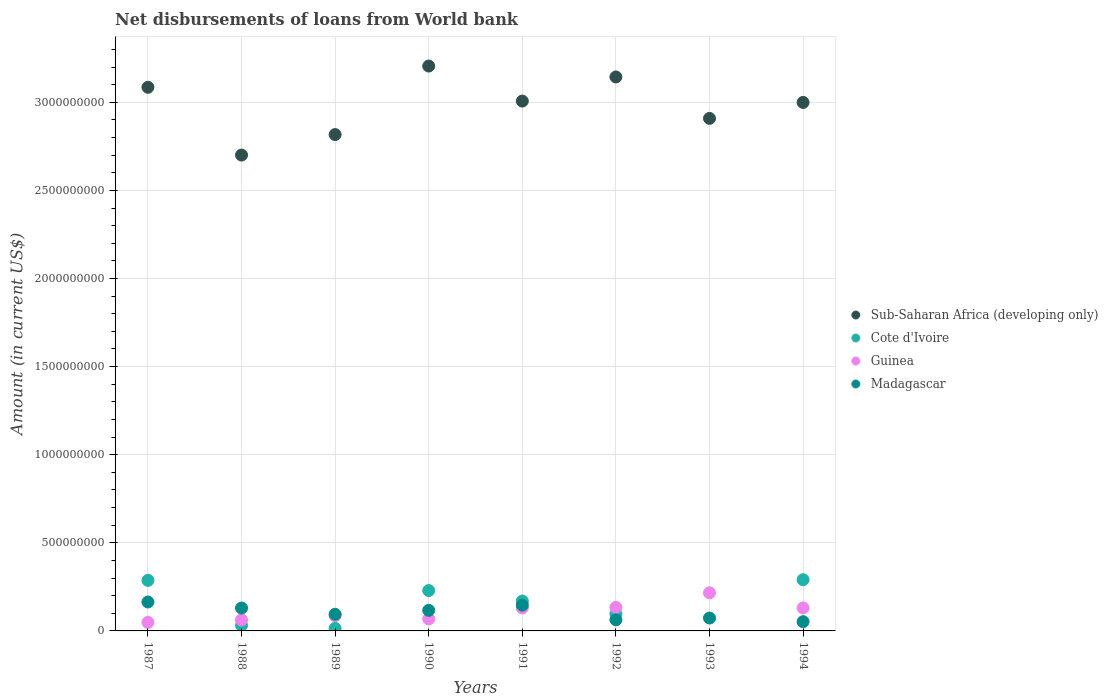What is the amount of loan disbursed from World Bank in Madagascar in 1994?
Your answer should be compact. 5.24e+07. Across all years, what is the maximum amount of loan disbursed from World Bank in Sub-Saharan Africa (developing only)?
Provide a short and direct response. 3.21e+09. In which year was the amount of loan disbursed from World Bank in Cote d'Ivoire maximum?
Keep it short and to the point. 1994. What is the total amount of loan disbursed from World Bank in Sub-Saharan Africa (developing only) in the graph?
Make the answer very short. 2.39e+1. What is the difference between the amount of loan disbursed from World Bank in Sub-Saharan Africa (developing only) in 1987 and that in 1991?
Offer a terse response. 7.83e+07. What is the difference between the amount of loan disbursed from World Bank in Madagascar in 1991 and the amount of loan disbursed from World Bank in Cote d'Ivoire in 1990?
Ensure brevity in your answer.  -8.31e+07. What is the average amount of loan disbursed from World Bank in Cote d'Ivoire per year?
Ensure brevity in your answer.  1.40e+08. In the year 1990, what is the difference between the amount of loan disbursed from World Bank in Cote d'Ivoire and amount of loan disbursed from World Bank in Sub-Saharan Africa (developing only)?
Provide a succinct answer. -2.98e+09. What is the ratio of the amount of loan disbursed from World Bank in Guinea in 1988 to that in 1989?
Offer a very short reply. 0.72. Is the amount of loan disbursed from World Bank in Cote d'Ivoire in 1987 less than that in 1989?
Provide a short and direct response. No. Is the difference between the amount of loan disbursed from World Bank in Cote d'Ivoire in 1988 and 1990 greater than the difference between the amount of loan disbursed from World Bank in Sub-Saharan Africa (developing only) in 1988 and 1990?
Keep it short and to the point. Yes. What is the difference between the highest and the second highest amount of loan disbursed from World Bank in Guinea?
Your response must be concise. 8.31e+07. What is the difference between the highest and the lowest amount of loan disbursed from World Bank in Cote d'Ivoire?
Your response must be concise. 2.91e+08. Is the sum of the amount of loan disbursed from World Bank in Guinea in 1988 and 1991 greater than the maximum amount of loan disbursed from World Bank in Sub-Saharan Africa (developing only) across all years?
Give a very brief answer. No. Is the amount of loan disbursed from World Bank in Sub-Saharan Africa (developing only) strictly greater than the amount of loan disbursed from World Bank in Cote d'Ivoire over the years?
Your answer should be very brief. Yes. Is the amount of loan disbursed from World Bank in Sub-Saharan Africa (developing only) strictly less than the amount of loan disbursed from World Bank in Madagascar over the years?
Offer a very short reply. No. How many dotlines are there?
Provide a short and direct response. 4. How many years are there in the graph?
Keep it short and to the point. 8. What is the difference between two consecutive major ticks on the Y-axis?
Make the answer very short. 5.00e+08. Does the graph contain grids?
Ensure brevity in your answer.  Yes. Where does the legend appear in the graph?
Your response must be concise. Center right. How are the legend labels stacked?
Your answer should be very brief. Vertical. What is the title of the graph?
Your response must be concise. Net disbursements of loans from World bank. What is the label or title of the X-axis?
Make the answer very short. Years. What is the label or title of the Y-axis?
Ensure brevity in your answer.  Amount (in current US$). What is the Amount (in current US$) of Sub-Saharan Africa (developing only) in 1987?
Offer a terse response. 3.09e+09. What is the Amount (in current US$) in Cote d'Ivoire in 1987?
Give a very brief answer. 2.87e+08. What is the Amount (in current US$) in Guinea in 1987?
Keep it short and to the point. 4.83e+07. What is the Amount (in current US$) in Madagascar in 1987?
Ensure brevity in your answer.  1.64e+08. What is the Amount (in current US$) of Sub-Saharan Africa (developing only) in 1988?
Provide a succinct answer. 2.70e+09. What is the Amount (in current US$) in Cote d'Ivoire in 1988?
Provide a short and direct response. 3.14e+07. What is the Amount (in current US$) of Guinea in 1988?
Make the answer very short. 6.24e+07. What is the Amount (in current US$) of Madagascar in 1988?
Offer a very short reply. 1.30e+08. What is the Amount (in current US$) of Sub-Saharan Africa (developing only) in 1989?
Your answer should be very brief. 2.82e+09. What is the Amount (in current US$) in Cote d'Ivoire in 1989?
Your answer should be very brief. 1.43e+07. What is the Amount (in current US$) in Guinea in 1989?
Your response must be concise. 8.67e+07. What is the Amount (in current US$) in Madagascar in 1989?
Provide a succinct answer. 9.44e+07. What is the Amount (in current US$) of Sub-Saharan Africa (developing only) in 1990?
Offer a terse response. 3.21e+09. What is the Amount (in current US$) of Cote d'Ivoire in 1990?
Offer a very short reply. 2.29e+08. What is the Amount (in current US$) of Guinea in 1990?
Make the answer very short. 6.82e+07. What is the Amount (in current US$) in Madagascar in 1990?
Your response must be concise. 1.17e+08. What is the Amount (in current US$) in Sub-Saharan Africa (developing only) in 1991?
Ensure brevity in your answer.  3.01e+09. What is the Amount (in current US$) of Cote d'Ivoire in 1991?
Keep it short and to the point. 1.70e+08. What is the Amount (in current US$) in Guinea in 1991?
Provide a succinct answer. 1.31e+08. What is the Amount (in current US$) in Madagascar in 1991?
Make the answer very short. 1.46e+08. What is the Amount (in current US$) in Sub-Saharan Africa (developing only) in 1992?
Your response must be concise. 3.14e+09. What is the Amount (in current US$) of Cote d'Ivoire in 1992?
Your answer should be very brief. 9.70e+07. What is the Amount (in current US$) of Guinea in 1992?
Offer a very short reply. 1.33e+08. What is the Amount (in current US$) in Madagascar in 1992?
Your response must be concise. 6.29e+07. What is the Amount (in current US$) in Sub-Saharan Africa (developing only) in 1993?
Give a very brief answer. 2.91e+09. What is the Amount (in current US$) in Cote d'Ivoire in 1993?
Your answer should be compact. 0. What is the Amount (in current US$) of Guinea in 1993?
Offer a terse response. 2.16e+08. What is the Amount (in current US$) in Madagascar in 1993?
Your answer should be very brief. 7.31e+07. What is the Amount (in current US$) of Sub-Saharan Africa (developing only) in 1994?
Offer a terse response. 3.00e+09. What is the Amount (in current US$) of Cote d'Ivoire in 1994?
Offer a very short reply. 2.91e+08. What is the Amount (in current US$) in Guinea in 1994?
Your answer should be compact. 1.31e+08. What is the Amount (in current US$) in Madagascar in 1994?
Ensure brevity in your answer.  5.24e+07. Across all years, what is the maximum Amount (in current US$) of Sub-Saharan Africa (developing only)?
Ensure brevity in your answer.  3.21e+09. Across all years, what is the maximum Amount (in current US$) of Cote d'Ivoire?
Provide a succinct answer. 2.91e+08. Across all years, what is the maximum Amount (in current US$) in Guinea?
Your answer should be compact. 2.16e+08. Across all years, what is the maximum Amount (in current US$) in Madagascar?
Provide a short and direct response. 1.64e+08. Across all years, what is the minimum Amount (in current US$) in Sub-Saharan Africa (developing only)?
Ensure brevity in your answer.  2.70e+09. Across all years, what is the minimum Amount (in current US$) of Guinea?
Your answer should be compact. 4.83e+07. Across all years, what is the minimum Amount (in current US$) of Madagascar?
Provide a short and direct response. 5.24e+07. What is the total Amount (in current US$) of Sub-Saharan Africa (developing only) in the graph?
Provide a succinct answer. 2.39e+1. What is the total Amount (in current US$) in Cote d'Ivoire in the graph?
Keep it short and to the point. 1.12e+09. What is the total Amount (in current US$) of Guinea in the graph?
Your answer should be compact. 8.77e+08. What is the total Amount (in current US$) in Madagascar in the graph?
Your response must be concise. 8.40e+08. What is the difference between the Amount (in current US$) in Sub-Saharan Africa (developing only) in 1987 and that in 1988?
Make the answer very short. 3.85e+08. What is the difference between the Amount (in current US$) of Cote d'Ivoire in 1987 and that in 1988?
Keep it short and to the point. 2.55e+08. What is the difference between the Amount (in current US$) of Guinea in 1987 and that in 1988?
Your answer should be compact. -1.41e+07. What is the difference between the Amount (in current US$) in Madagascar in 1987 and that in 1988?
Ensure brevity in your answer.  3.42e+07. What is the difference between the Amount (in current US$) of Sub-Saharan Africa (developing only) in 1987 and that in 1989?
Make the answer very short. 2.68e+08. What is the difference between the Amount (in current US$) of Cote d'Ivoire in 1987 and that in 1989?
Offer a very short reply. 2.72e+08. What is the difference between the Amount (in current US$) in Guinea in 1987 and that in 1989?
Offer a very short reply. -3.84e+07. What is the difference between the Amount (in current US$) of Madagascar in 1987 and that in 1989?
Provide a succinct answer. 6.98e+07. What is the difference between the Amount (in current US$) of Sub-Saharan Africa (developing only) in 1987 and that in 1990?
Your answer should be compact. -1.20e+08. What is the difference between the Amount (in current US$) of Cote d'Ivoire in 1987 and that in 1990?
Provide a succinct answer. 5.76e+07. What is the difference between the Amount (in current US$) in Guinea in 1987 and that in 1990?
Offer a terse response. -1.99e+07. What is the difference between the Amount (in current US$) of Madagascar in 1987 and that in 1990?
Ensure brevity in your answer.  4.74e+07. What is the difference between the Amount (in current US$) in Sub-Saharan Africa (developing only) in 1987 and that in 1991?
Make the answer very short. 7.83e+07. What is the difference between the Amount (in current US$) of Cote d'Ivoire in 1987 and that in 1991?
Give a very brief answer. 1.17e+08. What is the difference between the Amount (in current US$) of Guinea in 1987 and that in 1991?
Offer a terse response. -8.24e+07. What is the difference between the Amount (in current US$) in Madagascar in 1987 and that in 1991?
Ensure brevity in your answer.  1.81e+07. What is the difference between the Amount (in current US$) in Sub-Saharan Africa (developing only) in 1987 and that in 1992?
Your answer should be compact. -5.87e+07. What is the difference between the Amount (in current US$) in Cote d'Ivoire in 1987 and that in 1992?
Keep it short and to the point. 1.90e+08. What is the difference between the Amount (in current US$) of Guinea in 1987 and that in 1992?
Keep it short and to the point. -8.50e+07. What is the difference between the Amount (in current US$) in Madagascar in 1987 and that in 1992?
Provide a succinct answer. 1.01e+08. What is the difference between the Amount (in current US$) in Sub-Saharan Africa (developing only) in 1987 and that in 1993?
Make the answer very short. 1.77e+08. What is the difference between the Amount (in current US$) of Guinea in 1987 and that in 1993?
Your response must be concise. -1.68e+08. What is the difference between the Amount (in current US$) of Madagascar in 1987 and that in 1993?
Your answer should be very brief. 9.11e+07. What is the difference between the Amount (in current US$) in Sub-Saharan Africa (developing only) in 1987 and that in 1994?
Offer a terse response. 8.60e+07. What is the difference between the Amount (in current US$) in Cote d'Ivoire in 1987 and that in 1994?
Your response must be concise. -3.87e+06. What is the difference between the Amount (in current US$) of Guinea in 1987 and that in 1994?
Your response must be concise. -8.23e+07. What is the difference between the Amount (in current US$) of Madagascar in 1987 and that in 1994?
Ensure brevity in your answer.  1.12e+08. What is the difference between the Amount (in current US$) of Sub-Saharan Africa (developing only) in 1988 and that in 1989?
Ensure brevity in your answer.  -1.16e+08. What is the difference between the Amount (in current US$) in Cote d'Ivoire in 1988 and that in 1989?
Offer a very short reply. 1.71e+07. What is the difference between the Amount (in current US$) in Guinea in 1988 and that in 1989?
Provide a succinct answer. -2.43e+07. What is the difference between the Amount (in current US$) of Madagascar in 1988 and that in 1989?
Your answer should be very brief. 3.56e+07. What is the difference between the Amount (in current US$) of Sub-Saharan Africa (developing only) in 1988 and that in 1990?
Provide a succinct answer. -5.05e+08. What is the difference between the Amount (in current US$) of Cote d'Ivoire in 1988 and that in 1990?
Offer a very short reply. -1.98e+08. What is the difference between the Amount (in current US$) of Guinea in 1988 and that in 1990?
Ensure brevity in your answer.  -5.80e+06. What is the difference between the Amount (in current US$) of Madagascar in 1988 and that in 1990?
Your response must be concise. 1.32e+07. What is the difference between the Amount (in current US$) of Sub-Saharan Africa (developing only) in 1988 and that in 1991?
Provide a succinct answer. -3.06e+08. What is the difference between the Amount (in current US$) of Cote d'Ivoire in 1988 and that in 1991?
Your response must be concise. -1.38e+08. What is the difference between the Amount (in current US$) in Guinea in 1988 and that in 1991?
Keep it short and to the point. -6.82e+07. What is the difference between the Amount (in current US$) of Madagascar in 1988 and that in 1991?
Ensure brevity in your answer.  -1.61e+07. What is the difference between the Amount (in current US$) in Sub-Saharan Africa (developing only) in 1988 and that in 1992?
Your response must be concise. -4.43e+08. What is the difference between the Amount (in current US$) in Cote d'Ivoire in 1988 and that in 1992?
Offer a very short reply. -6.56e+07. What is the difference between the Amount (in current US$) of Guinea in 1988 and that in 1992?
Provide a succinct answer. -7.09e+07. What is the difference between the Amount (in current US$) in Madagascar in 1988 and that in 1992?
Provide a short and direct response. 6.71e+07. What is the difference between the Amount (in current US$) in Sub-Saharan Africa (developing only) in 1988 and that in 1993?
Provide a short and direct response. -2.08e+08. What is the difference between the Amount (in current US$) of Guinea in 1988 and that in 1993?
Your answer should be compact. -1.54e+08. What is the difference between the Amount (in current US$) of Madagascar in 1988 and that in 1993?
Ensure brevity in your answer.  5.68e+07. What is the difference between the Amount (in current US$) in Sub-Saharan Africa (developing only) in 1988 and that in 1994?
Offer a very short reply. -2.99e+08. What is the difference between the Amount (in current US$) in Cote d'Ivoire in 1988 and that in 1994?
Provide a succinct answer. -2.59e+08. What is the difference between the Amount (in current US$) in Guinea in 1988 and that in 1994?
Provide a short and direct response. -6.82e+07. What is the difference between the Amount (in current US$) in Madagascar in 1988 and that in 1994?
Ensure brevity in your answer.  7.76e+07. What is the difference between the Amount (in current US$) of Sub-Saharan Africa (developing only) in 1989 and that in 1990?
Provide a short and direct response. -3.89e+08. What is the difference between the Amount (in current US$) of Cote d'Ivoire in 1989 and that in 1990?
Give a very brief answer. -2.15e+08. What is the difference between the Amount (in current US$) of Guinea in 1989 and that in 1990?
Your answer should be very brief. 1.85e+07. What is the difference between the Amount (in current US$) of Madagascar in 1989 and that in 1990?
Ensure brevity in your answer.  -2.23e+07. What is the difference between the Amount (in current US$) in Sub-Saharan Africa (developing only) in 1989 and that in 1991?
Your answer should be very brief. -1.90e+08. What is the difference between the Amount (in current US$) of Cote d'Ivoire in 1989 and that in 1991?
Your answer should be compact. -1.56e+08. What is the difference between the Amount (in current US$) in Guinea in 1989 and that in 1991?
Provide a succinct answer. -4.40e+07. What is the difference between the Amount (in current US$) in Madagascar in 1989 and that in 1991?
Provide a succinct answer. -5.17e+07. What is the difference between the Amount (in current US$) in Sub-Saharan Africa (developing only) in 1989 and that in 1992?
Keep it short and to the point. -3.27e+08. What is the difference between the Amount (in current US$) of Cote d'Ivoire in 1989 and that in 1992?
Ensure brevity in your answer.  -8.27e+07. What is the difference between the Amount (in current US$) in Guinea in 1989 and that in 1992?
Your answer should be very brief. -4.66e+07. What is the difference between the Amount (in current US$) in Madagascar in 1989 and that in 1992?
Your answer should be very brief. 3.15e+07. What is the difference between the Amount (in current US$) in Sub-Saharan Africa (developing only) in 1989 and that in 1993?
Provide a short and direct response. -9.18e+07. What is the difference between the Amount (in current US$) in Guinea in 1989 and that in 1993?
Provide a succinct answer. -1.30e+08. What is the difference between the Amount (in current US$) in Madagascar in 1989 and that in 1993?
Provide a short and direct response. 2.13e+07. What is the difference between the Amount (in current US$) of Sub-Saharan Africa (developing only) in 1989 and that in 1994?
Your answer should be compact. -1.82e+08. What is the difference between the Amount (in current US$) in Cote d'Ivoire in 1989 and that in 1994?
Give a very brief answer. -2.76e+08. What is the difference between the Amount (in current US$) of Guinea in 1989 and that in 1994?
Your answer should be compact. -4.40e+07. What is the difference between the Amount (in current US$) in Madagascar in 1989 and that in 1994?
Your response must be concise. 4.21e+07. What is the difference between the Amount (in current US$) of Sub-Saharan Africa (developing only) in 1990 and that in 1991?
Offer a very short reply. 1.99e+08. What is the difference between the Amount (in current US$) in Cote d'Ivoire in 1990 and that in 1991?
Your response must be concise. 5.94e+07. What is the difference between the Amount (in current US$) of Guinea in 1990 and that in 1991?
Keep it short and to the point. -6.25e+07. What is the difference between the Amount (in current US$) of Madagascar in 1990 and that in 1991?
Give a very brief answer. -2.94e+07. What is the difference between the Amount (in current US$) in Sub-Saharan Africa (developing only) in 1990 and that in 1992?
Your response must be concise. 6.18e+07. What is the difference between the Amount (in current US$) in Cote d'Ivoire in 1990 and that in 1992?
Offer a very short reply. 1.32e+08. What is the difference between the Amount (in current US$) of Guinea in 1990 and that in 1992?
Make the answer very short. -6.51e+07. What is the difference between the Amount (in current US$) in Madagascar in 1990 and that in 1992?
Your answer should be compact. 5.39e+07. What is the difference between the Amount (in current US$) in Sub-Saharan Africa (developing only) in 1990 and that in 1993?
Your answer should be compact. 2.97e+08. What is the difference between the Amount (in current US$) of Guinea in 1990 and that in 1993?
Keep it short and to the point. -1.48e+08. What is the difference between the Amount (in current US$) of Madagascar in 1990 and that in 1993?
Give a very brief answer. 4.36e+07. What is the difference between the Amount (in current US$) in Sub-Saharan Africa (developing only) in 1990 and that in 1994?
Offer a very short reply. 2.06e+08. What is the difference between the Amount (in current US$) in Cote d'Ivoire in 1990 and that in 1994?
Keep it short and to the point. -6.15e+07. What is the difference between the Amount (in current US$) in Guinea in 1990 and that in 1994?
Offer a very short reply. -6.24e+07. What is the difference between the Amount (in current US$) of Madagascar in 1990 and that in 1994?
Keep it short and to the point. 6.44e+07. What is the difference between the Amount (in current US$) of Sub-Saharan Africa (developing only) in 1991 and that in 1992?
Keep it short and to the point. -1.37e+08. What is the difference between the Amount (in current US$) of Cote d'Ivoire in 1991 and that in 1992?
Your response must be concise. 7.29e+07. What is the difference between the Amount (in current US$) in Guinea in 1991 and that in 1992?
Ensure brevity in your answer.  -2.63e+06. What is the difference between the Amount (in current US$) in Madagascar in 1991 and that in 1992?
Keep it short and to the point. 8.32e+07. What is the difference between the Amount (in current US$) in Sub-Saharan Africa (developing only) in 1991 and that in 1993?
Offer a terse response. 9.82e+07. What is the difference between the Amount (in current US$) in Guinea in 1991 and that in 1993?
Offer a very short reply. -8.58e+07. What is the difference between the Amount (in current US$) of Madagascar in 1991 and that in 1993?
Offer a very short reply. 7.30e+07. What is the difference between the Amount (in current US$) in Sub-Saharan Africa (developing only) in 1991 and that in 1994?
Provide a short and direct response. 7.68e+06. What is the difference between the Amount (in current US$) of Cote d'Ivoire in 1991 and that in 1994?
Your answer should be very brief. -1.21e+08. What is the difference between the Amount (in current US$) of Guinea in 1991 and that in 1994?
Make the answer very short. 3.80e+04. What is the difference between the Amount (in current US$) in Madagascar in 1991 and that in 1994?
Your answer should be very brief. 9.37e+07. What is the difference between the Amount (in current US$) of Sub-Saharan Africa (developing only) in 1992 and that in 1993?
Give a very brief answer. 2.35e+08. What is the difference between the Amount (in current US$) of Guinea in 1992 and that in 1993?
Offer a very short reply. -8.31e+07. What is the difference between the Amount (in current US$) of Madagascar in 1992 and that in 1993?
Offer a terse response. -1.03e+07. What is the difference between the Amount (in current US$) in Sub-Saharan Africa (developing only) in 1992 and that in 1994?
Give a very brief answer. 1.45e+08. What is the difference between the Amount (in current US$) in Cote d'Ivoire in 1992 and that in 1994?
Ensure brevity in your answer.  -1.94e+08. What is the difference between the Amount (in current US$) in Guinea in 1992 and that in 1994?
Your answer should be compact. 2.67e+06. What is the difference between the Amount (in current US$) of Madagascar in 1992 and that in 1994?
Offer a terse response. 1.05e+07. What is the difference between the Amount (in current US$) in Sub-Saharan Africa (developing only) in 1993 and that in 1994?
Your response must be concise. -9.06e+07. What is the difference between the Amount (in current US$) of Guinea in 1993 and that in 1994?
Provide a succinct answer. 8.58e+07. What is the difference between the Amount (in current US$) of Madagascar in 1993 and that in 1994?
Offer a very short reply. 2.08e+07. What is the difference between the Amount (in current US$) in Sub-Saharan Africa (developing only) in 1987 and the Amount (in current US$) in Cote d'Ivoire in 1988?
Make the answer very short. 3.05e+09. What is the difference between the Amount (in current US$) of Sub-Saharan Africa (developing only) in 1987 and the Amount (in current US$) of Guinea in 1988?
Your response must be concise. 3.02e+09. What is the difference between the Amount (in current US$) in Sub-Saharan Africa (developing only) in 1987 and the Amount (in current US$) in Madagascar in 1988?
Give a very brief answer. 2.96e+09. What is the difference between the Amount (in current US$) of Cote d'Ivoire in 1987 and the Amount (in current US$) of Guinea in 1988?
Make the answer very short. 2.24e+08. What is the difference between the Amount (in current US$) in Cote d'Ivoire in 1987 and the Amount (in current US$) in Madagascar in 1988?
Your response must be concise. 1.57e+08. What is the difference between the Amount (in current US$) in Guinea in 1987 and the Amount (in current US$) in Madagascar in 1988?
Make the answer very short. -8.17e+07. What is the difference between the Amount (in current US$) of Sub-Saharan Africa (developing only) in 1987 and the Amount (in current US$) of Cote d'Ivoire in 1989?
Give a very brief answer. 3.07e+09. What is the difference between the Amount (in current US$) in Sub-Saharan Africa (developing only) in 1987 and the Amount (in current US$) in Guinea in 1989?
Offer a terse response. 3.00e+09. What is the difference between the Amount (in current US$) in Sub-Saharan Africa (developing only) in 1987 and the Amount (in current US$) in Madagascar in 1989?
Your answer should be very brief. 2.99e+09. What is the difference between the Amount (in current US$) in Cote d'Ivoire in 1987 and the Amount (in current US$) in Guinea in 1989?
Provide a short and direct response. 2.00e+08. What is the difference between the Amount (in current US$) in Cote d'Ivoire in 1987 and the Amount (in current US$) in Madagascar in 1989?
Your response must be concise. 1.92e+08. What is the difference between the Amount (in current US$) in Guinea in 1987 and the Amount (in current US$) in Madagascar in 1989?
Give a very brief answer. -4.61e+07. What is the difference between the Amount (in current US$) in Sub-Saharan Africa (developing only) in 1987 and the Amount (in current US$) in Cote d'Ivoire in 1990?
Provide a short and direct response. 2.86e+09. What is the difference between the Amount (in current US$) in Sub-Saharan Africa (developing only) in 1987 and the Amount (in current US$) in Guinea in 1990?
Give a very brief answer. 3.02e+09. What is the difference between the Amount (in current US$) in Sub-Saharan Africa (developing only) in 1987 and the Amount (in current US$) in Madagascar in 1990?
Your response must be concise. 2.97e+09. What is the difference between the Amount (in current US$) in Cote d'Ivoire in 1987 and the Amount (in current US$) in Guinea in 1990?
Your response must be concise. 2.19e+08. What is the difference between the Amount (in current US$) in Cote d'Ivoire in 1987 and the Amount (in current US$) in Madagascar in 1990?
Ensure brevity in your answer.  1.70e+08. What is the difference between the Amount (in current US$) in Guinea in 1987 and the Amount (in current US$) in Madagascar in 1990?
Give a very brief answer. -6.84e+07. What is the difference between the Amount (in current US$) in Sub-Saharan Africa (developing only) in 1987 and the Amount (in current US$) in Cote d'Ivoire in 1991?
Make the answer very short. 2.92e+09. What is the difference between the Amount (in current US$) of Sub-Saharan Africa (developing only) in 1987 and the Amount (in current US$) of Guinea in 1991?
Give a very brief answer. 2.95e+09. What is the difference between the Amount (in current US$) of Sub-Saharan Africa (developing only) in 1987 and the Amount (in current US$) of Madagascar in 1991?
Ensure brevity in your answer.  2.94e+09. What is the difference between the Amount (in current US$) of Cote d'Ivoire in 1987 and the Amount (in current US$) of Guinea in 1991?
Make the answer very short. 1.56e+08. What is the difference between the Amount (in current US$) in Cote d'Ivoire in 1987 and the Amount (in current US$) in Madagascar in 1991?
Your answer should be compact. 1.41e+08. What is the difference between the Amount (in current US$) of Guinea in 1987 and the Amount (in current US$) of Madagascar in 1991?
Make the answer very short. -9.78e+07. What is the difference between the Amount (in current US$) in Sub-Saharan Africa (developing only) in 1987 and the Amount (in current US$) in Cote d'Ivoire in 1992?
Provide a short and direct response. 2.99e+09. What is the difference between the Amount (in current US$) in Sub-Saharan Africa (developing only) in 1987 and the Amount (in current US$) in Guinea in 1992?
Offer a terse response. 2.95e+09. What is the difference between the Amount (in current US$) in Sub-Saharan Africa (developing only) in 1987 and the Amount (in current US$) in Madagascar in 1992?
Provide a succinct answer. 3.02e+09. What is the difference between the Amount (in current US$) in Cote d'Ivoire in 1987 and the Amount (in current US$) in Guinea in 1992?
Your answer should be compact. 1.54e+08. What is the difference between the Amount (in current US$) in Cote d'Ivoire in 1987 and the Amount (in current US$) in Madagascar in 1992?
Provide a short and direct response. 2.24e+08. What is the difference between the Amount (in current US$) of Guinea in 1987 and the Amount (in current US$) of Madagascar in 1992?
Make the answer very short. -1.46e+07. What is the difference between the Amount (in current US$) in Sub-Saharan Africa (developing only) in 1987 and the Amount (in current US$) in Guinea in 1993?
Your answer should be very brief. 2.87e+09. What is the difference between the Amount (in current US$) of Sub-Saharan Africa (developing only) in 1987 and the Amount (in current US$) of Madagascar in 1993?
Provide a succinct answer. 3.01e+09. What is the difference between the Amount (in current US$) of Cote d'Ivoire in 1987 and the Amount (in current US$) of Guinea in 1993?
Ensure brevity in your answer.  7.04e+07. What is the difference between the Amount (in current US$) in Cote d'Ivoire in 1987 and the Amount (in current US$) in Madagascar in 1993?
Offer a very short reply. 2.14e+08. What is the difference between the Amount (in current US$) in Guinea in 1987 and the Amount (in current US$) in Madagascar in 1993?
Offer a terse response. -2.48e+07. What is the difference between the Amount (in current US$) in Sub-Saharan Africa (developing only) in 1987 and the Amount (in current US$) in Cote d'Ivoire in 1994?
Give a very brief answer. 2.79e+09. What is the difference between the Amount (in current US$) in Sub-Saharan Africa (developing only) in 1987 and the Amount (in current US$) in Guinea in 1994?
Provide a short and direct response. 2.95e+09. What is the difference between the Amount (in current US$) in Sub-Saharan Africa (developing only) in 1987 and the Amount (in current US$) in Madagascar in 1994?
Your response must be concise. 3.03e+09. What is the difference between the Amount (in current US$) of Cote d'Ivoire in 1987 and the Amount (in current US$) of Guinea in 1994?
Make the answer very short. 1.56e+08. What is the difference between the Amount (in current US$) in Cote d'Ivoire in 1987 and the Amount (in current US$) in Madagascar in 1994?
Offer a terse response. 2.34e+08. What is the difference between the Amount (in current US$) in Guinea in 1987 and the Amount (in current US$) in Madagascar in 1994?
Provide a short and direct response. -4.06e+06. What is the difference between the Amount (in current US$) of Sub-Saharan Africa (developing only) in 1988 and the Amount (in current US$) of Cote d'Ivoire in 1989?
Provide a succinct answer. 2.69e+09. What is the difference between the Amount (in current US$) of Sub-Saharan Africa (developing only) in 1988 and the Amount (in current US$) of Guinea in 1989?
Provide a short and direct response. 2.61e+09. What is the difference between the Amount (in current US$) of Sub-Saharan Africa (developing only) in 1988 and the Amount (in current US$) of Madagascar in 1989?
Offer a very short reply. 2.61e+09. What is the difference between the Amount (in current US$) of Cote d'Ivoire in 1988 and the Amount (in current US$) of Guinea in 1989?
Make the answer very short. -5.53e+07. What is the difference between the Amount (in current US$) in Cote d'Ivoire in 1988 and the Amount (in current US$) in Madagascar in 1989?
Your answer should be very brief. -6.30e+07. What is the difference between the Amount (in current US$) in Guinea in 1988 and the Amount (in current US$) in Madagascar in 1989?
Offer a terse response. -3.20e+07. What is the difference between the Amount (in current US$) in Sub-Saharan Africa (developing only) in 1988 and the Amount (in current US$) in Cote d'Ivoire in 1990?
Keep it short and to the point. 2.47e+09. What is the difference between the Amount (in current US$) in Sub-Saharan Africa (developing only) in 1988 and the Amount (in current US$) in Guinea in 1990?
Provide a short and direct response. 2.63e+09. What is the difference between the Amount (in current US$) of Sub-Saharan Africa (developing only) in 1988 and the Amount (in current US$) of Madagascar in 1990?
Give a very brief answer. 2.58e+09. What is the difference between the Amount (in current US$) of Cote d'Ivoire in 1988 and the Amount (in current US$) of Guinea in 1990?
Your answer should be very brief. -3.68e+07. What is the difference between the Amount (in current US$) of Cote d'Ivoire in 1988 and the Amount (in current US$) of Madagascar in 1990?
Ensure brevity in your answer.  -8.53e+07. What is the difference between the Amount (in current US$) of Guinea in 1988 and the Amount (in current US$) of Madagascar in 1990?
Offer a very short reply. -5.43e+07. What is the difference between the Amount (in current US$) of Sub-Saharan Africa (developing only) in 1988 and the Amount (in current US$) of Cote d'Ivoire in 1991?
Offer a very short reply. 2.53e+09. What is the difference between the Amount (in current US$) in Sub-Saharan Africa (developing only) in 1988 and the Amount (in current US$) in Guinea in 1991?
Ensure brevity in your answer.  2.57e+09. What is the difference between the Amount (in current US$) in Sub-Saharan Africa (developing only) in 1988 and the Amount (in current US$) in Madagascar in 1991?
Give a very brief answer. 2.55e+09. What is the difference between the Amount (in current US$) of Cote d'Ivoire in 1988 and the Amount (in current US$) of Guinea in 1991?
Your answer should be compact. -9.93e+07. What is the difference between the Amount (in current US$) in Cote d'Ivoire in 1988 and the Amount (in current US$) in Madagascar in 1991?
Offer a very short reply. -1.15e+08. What is the difference between the Amount (in current US$) in Guinea in 1988 and the Amount (in current US$) in Madagascar in 1991?
Offer a very short reply. -8.37e+07. What is the difference between the Amount (in current US$) in Sub-Saharan Africa (developing only) in 1988 and the Amount (in current US$) in Cote d'Ivoire in 1992?
Make the answer very short. 2.60e+09. What is the difference between the Amount (in current US$) in Sub-Saharan Africa (developing only) in 1988 and the Amount (in current US$) in Guinea in 1992?
Provide a short and direct response. 2.57e+09. What is the difference between the Amount (in current US$) of Sub-Saharan Africa (developing only) in 1988 and the Amount (in current US$) of Madagascar in 1992?
Keep it short and to the point. 2.64e+09. What is the difference between the Amount (in current US$) in Cote d'Ivoire in 1988 and the Amount (in current US$) in Guinea in 1992?
Make the answer very short. -1.02e+08. What is the difference between the Amount (in current US$) in Cote d'Ivoire in 1988 and the Amount (in current US$) in Madagascar in 1992?
Offer a very short reply. -3.15e+07. What is the difference between the Amount (in current US$) of Guinea in 1988 and the Amount (in current US$) of Madagascar in 1992?
Give a very brief answer. -4.48e+05. What is the difference between the Amount (in current US$) of Sub-Saharan Africa (developing only) in 1988 and the Amount (in current US$) of Guinea in 1993?
Make the answer very short. 2.48e+09. What is the difference between the Amount (in current US$) in Sub-Saharan Africa (developing only) in 1988 and the Amount (in current US$) in Madagascar in 1993?
Provide a short and direct response. 2.63e+09. What is the difference between the Amount (in current US$) of Cote d'Ivoire in 1988 and the Amount (in current US$) of Guinea in 1993?
Make the answer very short. -1.85e+08. What is the difference between the Amount (in current US$) of Cote d'Ivoire in 1988 and the Amount (in current US$) of Madagascar in 1993?
Offer a terse response. -4.17e+07. What is the difference between the Amount (in current US$) of Guinea in 1988 and the Amount (in current US$) of Madagascar in 1993?
Provide a short and direct response. -1.07e+07. What is the difference between the Amount (in current US$) in Sub-Saharan Africa (developing only) in 1988 and the Amount (in current US$) in Cote d'Ivoire in 1994?
Give a very brief answer. 2.41e+09. What is the difference between the Amount (in current US$) in Sub-Saharan Africa (developing only) in 1988 and the Amount (in current US$) in Guinea in 1994?
Offer a terse response. 2.57e+09. What is the difference between the Amount (in current US$) in Sub-Saharan Africa (developing only) in 1988 and the Amount (in current US$) in Madagascar in 1994?
Your answer should be compact. 2.65e+09. What is the difference between the Amount (in current US$) in Cote d'Ivoire in 1988 and the Amount (in current US$) in Guinea in 1994?
Offer a terse response. -9.92e+07. What is the difference between the Amount (in current US$) of Cote d'Ivoire in 1988 and the Amount (in current US$) of Madagascar in 1994?
Your response must be concise. -2.10e+07. What is the difference between the Amount (in current US$) of Guinea in 1988 and the Amount (in current US$) of Madagascar in 1994?
Offer a terse response. 1.01e+07. What is the difference between the Amount (in current US$) of Sub-Saharan Africa (developing only) in 1989 and the Amount (in current US$) of Cote d'Ivoire in 1990?
Your answer should be compact. 2.59e+09. What is the difference between the Amount (in current US$) in Sub-Saharan Africa (developing only) in 1989 and the Amount (in current US$) in Guinea in 1990?
Your answer should be compact. 2.75e+09. What is the difference between the Amount (in current US$) of Sub-Saharan Africa (developing only) in 1989 and the Amount (in current US$) of Madagascar in 1990?
Provide a succinct answer. 2.70e+09. What is the difference between the Amount (in current US$) in Cote d'Ivoire in 1989 and the Amount (in current US$) in Guinea in 1990?
Provide a short and direct response. -5.39e+07. What is the difference between the Amount (in current US$) of Cote d'Ivoire in 1989 and the Amount (in current US$) of Madagascar in 1990?
Provide a short and direct response. -1.02e+08. What is the difference between the Amount (in current US$) in Guinea in 1989 and the Amount (in current US$) in Madagascar in 1990?
Make the answer very short. -3.01e+07. What is the difference between the Amount (in current US$) in Sub-Saharan Africa (developing only) in 1989 and the Amount (in current US$) in Cote d'Ivoire in 1991?
Offer a very short reply. 2.65e+09. What is the difference between the Amount (in current US$) of Sub-Saharan Africa (developing only) in 1989 and the Amount (in current US$) of Guinea in 1991?
Your answer should be compact. 2.69e+09. What is the difference between the Amount (in current US$) of Sub-Saharan Africa (developing only) in 1989 and the Amount (in current US$) of Madagascar in 1991?
Offer a very short reply. 2.67e+09. What is the difference between the Amount (in current US$) in Cote d'Ivoire in 1989 and the Amount (in current US$) in Guinea in 1991?
Your answer should be compact. -1.16e+08. What is the difference between the Amount (in current US$) of Cote d'Ivoire in 1989 and the Amount (in current US$) of Madagascar in 1991?
Offer a terse response. -1.32e+08. What is the difference between the Amount (in current US$) of Guinea in 1989 and the Amount (in current US$) of Madagascar in 1991?
Keep it short and to the point. -5.94e+07. What is the difference between the Amount (in current US$) in Sub-Saharan Africa (developing only) in 1989 and the Amount (in current US$) in Cote d'Ivoire in 1992?
Provide a succinct answer. 2.72e+09. What is the difference between the Amount (in current US$) in Sub-Saharan Africa (developing only) in 1989 and the Amount (in current US$) in Guinea in 1992?
Your response must be concise. 2.68e+09. What is the difference between the Amount (in current US$) in Sub-Saharan Africa (developing only) in 1989 and the Amount (in current US$) in Madagascar in 1992?
Ensure brevity in your answer.  2.75e+09. What is the difference between the Amount (in current US$) in Cote d'Ivoire in 1989 and the Amount (in current US$) in Guinea in 1992?
Keep it short and to the point. -1.19e+08. What is the difference between the Amount (in current US$) of Cote d'Ivoire in 1989 and the Amount (in current US$) of Madagascar in 1992?
Provide a succinct answer. -4.85e+07. What is the difference between the Amount (in current US$) in Guinea in 1989 and the Amount (in current US$) in Madagascar in 1992?
Ensure brevity in your answer.  2.38e+07. What is the difference between the Amount (in current US$) of Sub-Saharan Africa (developing only) in 1989 and the Amount (in current US$) of Guinea in 1993?
Offer a very short reply. 2.60e+09. What is the difference between the Amount (in current US$) of Sub-Saharan Africa (developing only) in 1989 and the Amount (in current US$) of Madagascar in 1993?
Make the answer very short. 2.74e+09. What is the difference between the Amount (in current US$) in Cote d'Ivoire in 1989 and the Amount (in current US$) in Guinea in 1993?
Make the answer very short. -2.02e+08. What is the difference between the Amount (in current US$) of Cote d'Ivoire in 1989 and the Amount (in current US$) of Madagascar in 1993?
Your answer should be very brief. -5.88e+07. What is the difference between the Amount (in current US$) of Guinea in 1989 and the Amount (in current US$) of Madagascar in 1993?
Your answer should be compact. 1.35e+07. What is the difference between the Amount (in current US$) of Sub-Saharan Africa (developing only) in 1989 and the Amount (in current US$) of Cote d'Ivoire in 1994?
Keep it short and to the point. 2.53e+09. What is the difference between the Amount (in current US$) of Sub-Saharan Africa (developing only) in 1989 and the Amount (in current US$) of Guinea in 1994?
Your answer should be very brief. 2.69e+09. What is the difference between the Amount (in current US$) in Sub-Saharan Africa (developing only) in 1989 and the Amount (in current US$) in Madagascar in 1994?
Make the answer very short. 2.76e+09. What is the difference between the Amount (in current US$) of Cote d'Ivoire in 1989 and the Amount (in current US$) of Guinea in 1994?
Your answer should be very brief. -1.16e+08. What is the difference between the Amount (in current US$) of Cote d'Ivoire in 1989 and the Amount (in current US$) of Madagascar in 1994?
Ensure brevity in your answer.  -3.80e+07. What is the difference between the Amount (in current US$) of Guinea in 1989 and the Amount (in current US$) of Madagascar in 1994?
Your answer should be compact. 3.43e+07. What is the difference between the Amount (in current US$) of Sub-Saharan Africa (developing only) in 1990 and the Amount (in current US$) of Cote d'Ivoire in 1991?
Your answer should be compact. 3.04e+09. What is the difference between the Amount (in current US$) of Sub-Saharan Africa (developing only) in 1990 and the Amount (in current US$) of Guinea in 1991?
Give a very brief answer. 3.07e+09. What is the difference between the Amount (in current US$) of Sub-Saharan Africa (developing only) in 1990 and the Amount (in current US$) of Madagascar in 1991?
Offer a terse response. 3.06e+09. What is the difference between the Amount (in current US$) of Cote d'Ivoire in 1990 and the Amount (in current US$) of Guinea in 1991?
Your response must be concise. 9.86e+07. What is the difference between the Amount (in current US$) in Cote d'Ivoire in 1990 and the Amount (in current US$) in Madagascar in 1991?
Your response must be concise. 8.31e+07. What is the difference between the Amount (in current US$) of Guinea in 1990 and the Amount (in current US$) of Madagascar in 1991?
Provide a short and direct response. -7.79e+07. What is the difference between the Amount (in current US$) in Sub-Saharan Africa (developing only) in 1990 and the Amount (in current US$) in Cote d'Ivoire in 1992?
Ensure brevity in your answer.  3.11e+09. What is the difference between the Amount (in current US$) of Sub-Saharan Africa (developing only) in 1990 and the Amount (in current US$) of Guinea in 1992?
Ensure brevity in your answer.  3.07e+09. What is the difference between the Amount (in current US$) in Sub-Saharan Africa (developing only) in 1990 and the Amount (in current US$) in Madagascar in 1992?
Offer a very short reply. 3.14e+09. What is the difference between the Amount (in current US$) of Cote d'Ivoire in 1990 and the Amount (in current US$) of Guinea in 1992?
Your answer should be compact. 9.59e+07. What is the difference between the Amount (in current US$) of Cote d'Ivoire in 1990 and the Amount (in current US$) of Madagascar in 1992?
Offer a terse response. 1.66e+08. What is the difference between the Amount (in current US$) of Guinea in 1990 and the Amount (in current US$) of Madagascar in 1992?
Your answer should be compact. 5.35e+06. What is the difference between the Amount (in current US$) in Sub-Saharan Africa (developing only) in 1990 and the Amount (in current US$) in Guinea in 1993?
Ensure brevity in your answer.  2.99e+09. What is the difference between the Amount (in current US$) of Sub-Saharan Africa (developing only) in 1990 and the Amount (in current US$) of Madagascar in 1993?
Offer a terse response. 3.13e+09. What is the difference between the Amount (in current US$) of Cote d'Ivoire in 1990 and the Amount (in current US$) of Guinea in 1993?
Keep it short and to the point. 1.28e+07. What is the difference between the Amount (in current US$) of Cote d'Ivoire in 1990 and the Amount (in current US$) of Madagascar in 1993?
Give a very brief answer. 1.56e+08. What is the difference between the Amount (in current US$) in Guinea in 1990 and the Amount (in current US$) in Madagascar in 1993?
Your response must be concise. -4.91e+06. What is the difference between the Amount (in current US$) of Sub-Saharan Africa (developing only) in 1990 and the Amount (in current US$) of Cote d'Ivoire in 1994?
Provide a succinct answer. 2.91e+09. What is the difference between the Amount (in current US$) in Sub-Saharan Africa (developing only) in 1990 and the Amount (in current US$) in Guinea in 1994?
Provide a succinct answer. 3.08e+09. What is the difference between the Amount (in current US$) in Sub-Saharan Africa (developing only) in 1990 and the Amount (in current US$) in Madagascar in 1994?
Offer a very short reply. 3.15e+09. What is the difference between the Amount (in current US$) of Cote d'Ivoire in 1990 and the Amount (in current US$) of Guinea in 1994?
Give a very brief answer. 9.86e+07. What is the difference between the Amount (in current US$) in Cote d'Ivoire in 1990 and the Amount (in current US$) in Madagascar in 1994?
Offer a very short reply. 1.77e+08. What is the difference between the Amount (in current US$) of Guinea in 1990 and the Amount (in current US$) of Madagascar in 1994?
Make the answer very short. 1.59e+07. What is the difference between the Amount (in current US$) of Sub-Saharan Africa (developing only) in 1991 and the Amount (in current US$) of Cote d'Ivoire in 1992?
Offer a very short reply. 2.91e+09. What is the difference between the Amount (in current US$) in Sub-Saharan Africa (developing only) in 1991 and the Amount (in current US$) in Guinea in 1992?
Provide a short and direct response. 2.87e+09. What is the difference between the Amount (in current US$) of Sub-Saharan Africa (developing only) in 1991 and the Amount (in current US$) of Madagascar in 1992?
Your answer should be compact. 2.94e+09. What is the difference between the Amount (in current US$) in Cote d'Ivoire in 1991 and the Amount (in current US$) in Guinea in 1992?
Offer a very short reply. 3.66e+07. What is the difference between the Amount (in current US$) in Cote d'Ivoire in 1991 and the Amount (in current US$) in Madagascar in 1992?
Offer a terse response. 1.07e+08. What is the difference between the Amount (in current US$) in Guinea in 1991 and the Amount (in current US$) in Madagascar in 1992?
Provide a succinct answer. 6.78e+07. What is the difference between the Amount (in current US$) of Sub-Saharan Africa (developing only) in 1991 and the Amount (in current US$) of Guinea in 1993?
Keep it short and to the point. 2.79e+09. What is the difference between the Amount (in current US$) of Sub-Saharan Africa (developing only) in 1991 and the Amount (in current US$) of Madagascar in 1993?
Provide a succinct answer. 2.93e+09. What is the difference between the Amount (in current US$) of Cote d'Ivoire in 1991 and the Amount (in current US$) of Guinea in 1993?
Offer a very short reply. -4.66e+07. What is the difference between the Amount (in current US$) in Cote d'Ivoire in 1991 and the Amount (in current US$) in Madagascar in 1993?
Keep it short and to the point. 9.67e+07. What is the difference between the Amount (in current US$) in Guinea in 1991 and the Amount (in current US$) in Madagascar in 1993?
Offer a terse response. 5.75e+07. What is the difference between the Amount (in current US$) of Sub-Saharan Africa (developing only) in 1991 and the Amount (in current US$) of Cote d'Ivoire in 1994?
Your answer should be compact. 2.72e+09. What is the difference between the Amount (in current US$) of Sub-Saharan Africa (developing only) in 1991 and the Amount (in current US$) of Guinea in 1994?
Your answer should be compact. 2.88e+09. What is the difference between the Amount (in current US$) of Sub-Saharan Africa (developing only) in 1991 and the Amount (in current US$) of Madagascar in 1994?
Give a very brief answer. 2.95e+09. What is the difference between the Amount (in current US$) in Cote d'Ivoire in 1991 and the Amount (in current US$) in Guinea in 1994?
Ensure brevity in your answer.  3.92e+07. What is the difference between the Amount (in current US$) in Cote d'Ivoire in 1991 and the Amount (in current US$) in Madagascar in 1994?
Your answer should be very brief. 1.18e+08. What is the difference between the Amount (in current US$) of Guinea in 1991 and the Amount (in current US$) of Madagascar in 1994?
Give a very brief answer. 7.83e+07. What is the difference between the Amount (in current US$) in Sub-Saharan Africa (developing only) in 1992 and the Amount (in current US$) in Guinea in 1993?
Your answer should be very brief. 2.93e+09. What is the difference between the Amount (in current US$) in Sub-Saharan Africa (developing only) in 1992 and the Amount (in current US$) in Madagascar in 1993?
Keep it short and to the point. 3.07e+09. What is the difference between the Amount (in current US$) in Cote d'Ivoire in 1992 and the Amount (in current US$) in Guinea in 1993?
Your response must be concise. -1.19e+08. What is the difference between the Amount (in current US$) of Cote d'Ivoire in 1992 and the Amount (in current US$) of Madagascar in 1993?
Your answer should be very brief. 2.39e+07. What is the difference between the Amount (in current US$) in Guinea in 1992 and the Amount (in current US$) in Madagascar in 1993?
Offer a very short reply. 6.02e+07. What is the difference between the Amount (in current US$) of Sub-Saharan Africa (developing only) in 1992 and the Amount (in current US$) of Cote d'Ivoire in 1994?
Offer a very short reply. 2.85e+09. What is the difference between the Amount (in current US$) of Sub-Saharan Africa (developing only) in 1992 and the Amount (in current US$) of Guinea in 1994?
Ensure brevity in your answer.  3.01e+09. What is the difference between the Amount (in current US$) in Sub-Saharan Africa (developing only) in 1992 and the Amount (in current US$) in Madagascar in 1994?
Your response must be concise. 3.09e+09. What is the difference between the Amount (in current US$) in Cote d'Ivoire in 1992 and the Amount (in current US$) in Guinea in 1994?
Make the answer very short. -3.36e+07. What is the difference between the Amount (in current US$) in Cote d'Ivoire in 1992 and the Amount (in current US$) in Madagascar in 1994?
Your response must be concise. 4.46e+07. What is the difference between the Amount (in current US$) in Guinea in 1992 and the Amount (in current US$) in Madagascar in 1994?
Your answer should be very brief. 8.09e+07. What is the difference between the Amount (in current US$) of Sub-Saharan Africa (developing only) in 1993 and the Amount (in current US$) of Cote d'Ivoire in 1994?
Ensure brevity in your answer.  2.62e+09. What is the difference between the Amount (in current US$) of Sub-Saharan Africa (developing only) in 1993 and the Amount (in current US$) of Guinea in 1994?
Keep it short and to the point. 2.78e+09. What is the difference between the Amount (in current US$) in Sub-Saharan Africa (developing only) in 1993 and the Amount (in current US$) in Madagascar in 1994?
Make the answer very short. 2.86e+09. What is the difference between the Amount (in current US$) of Guinea in 1993 and the Amount (in current US$) of Madagascar in 1994?
Make the answer very short. 1.64e+08. What is the average Amount (in current US$) in Sub-Saharan Africa (developing only) per year?
Offer a very short reply. 2.98e+09. What is the average Amount (in current US$) in Cote d'Ivoire per year?
Ensure brevity in your answer.  1.40e+08. What is the average Amount (in current US$) in Guinea per year?
Your answer should be very brief. 1.10e+08. What is the average Amount (in current US$) of Madagascar per year?
Provide a succinct answer. 1.05e+08. In the year 1987, what is the difference between the Amount (in current US$) of Sub-Saharan Africa (developing only) and Amount (in current US$) of Cote d'Ivoire?
Your answer should be compact. 2.80e+09. In the year 1987, what is the difference between the Amount (in current US$) of Sub-Saharan Africa (developing only) and Amount (in current US$) of Guinea?
Make the answer very short. 3.04e+09. In the year 1987, what is the difference between the Amount (in current US$) in Sub-Saharan Africa (developing only) and Amount (in current US$) in Madagascar?
Your answer should be very brief. 2.92e+09. In the year 1987, what is the difference between the Amount (in current US$) of Cote d'Ivoire and Amount (in current US$) of Guinea?
Your answer should be very brief. 2.39e+08. In the year 1987, what is the difference between the Amount (in current US$) in Cote d'Ivoire and Amount (in current US$) in Madagascar?
Make the answer very short. 1.23e+08. In the year 1987, what is the difference between the Amount (in current US$) of Guinea and Amount (in current US$) of Madagascar?
Make the answer very short. -1.16e+08. In the year 1988, what is the difference between the Amount (in current US$) in Sub-Saharan Africa (developing only) and Amount (in current US$) in Cote d'Ivoire?
Ensure brevity in your answer.  2.67e+09. In the year 1988, what is the difference between the Amount (in current US$) in Sub-Saharan Africa (developing only) and Amount (in current US$) in Guinea?
Your answer should be very brief. 2.64e+09. In the year 1988, what is the difference between the Amount (in current US$) of Sub-Saharan Africa (developing only) and Amount (in current US$) of Madagascar?
Provide a succinct answer. 2.57e+09. In the year 1988, what is the difference between the Amount (in current US$) in Cote d'Ivoire and Amount (in current US$) in Guinea?
Provide a succinct answer. -3.10e+07. In the year 1988, what is the difference between the Amount (in current US$) of Cote d'Ivoire and Amount (in current US$) of Madagascar?
Provide a short and direct response. -9.86e+07. In the year 1988, what is the difference between the Amount (in current US$) in Guinea and Amount (in current US$) in Madagascar?
Your response must be concise. -6.76e+07. In the year 1989, what is the difference between the Amount (in current US$) of Sub-Saharan Africa (developing only) and Amount (in current US$) of Cote d'Ivoire?
Offer a very short reply. 2.80e+09. In the year 1989, what is the difference between the Amount (in current US$) in Sub-Saharan Africa (developing only) and Amount (in current US$) in Guinea?
Offer a very short reply. 2.73e+09. In the year 1989, what is the difference between the Amount (in current US$) of Sub-Saharan Africa (developing only) and Amount (in current US$) of Madagascar?
Offer a very short reply. 2.72e+09. In the year 1989, what is the difference between the Amount (in current US$) of Cote d'Ivoire and Amount (in current US$) of Guinea?
Make the answer very short. -7.23e+07. In the year 1989, what is the difference between the Amount (in current US$) of Cote d'Ivoire and Amount (in current US$) of Madagascar?
Make the answer very short. -8.01e+07. In the year 1989, what is the difference between the Amount (in current US$) in Guinea and Amount (in current US$) in Madagascar?
Make the answer very short. -7.74e+06. In the year 1990, what is the difference between the Amount (in current US$) in Sub-Saharan Africa (developing only) and Amount (in current US$) in Cote d'Ivoire?
Your answer should be compact. 2.98e+09. In the year 1990, what is the difference between the Amount (in current US$) in Sub-Saharan Africa (developing only) and Amount (in current US$) in Guinea?
Make the answer very short. 3.14e+09. In the year 1990, what is the difference between the Amount (in current US$) in Sub-Saharan Africa (developing only) and Amount (in current US$) in Madagascar?
Give a very brief answer. 3.09e+09. In the year 1990, what is the difference between the Amount (in current US$) of Cote d'Ivoire and Amount (in current US$) of Guinea?
Provide a succinct answer. 1.61e+08. In the year 1990, what is the difference between the Amount (in current US$) in Cote d'Ivoire and Amount (in current US$) in Madagascar?
Offer a terse response. 1.12e+08. In the year 1990, what is the difference between the Amount (in current US$) in Guinea and Amount (in current US$) in Madagascar?
Make the answer very short. -4.85e+07. In the year 1991, what is the difference between the Amount (in current US$) in Sub-Saharan Africa (developing only) and Amount (in current US$) in Cote d'Ivoire?
Give a very brief answer. 2.84e+09. In the year 1991, what is the difference between the Amount (in current US$) of Sub-Saharan Africa (developing only) and Amount (in current US$) of Guinea?
Give a very brief answer. 2.88e+09. In the year 1991, what is the difference between the Amount (in current US$) in Sub-Saharan Africa (developing only) and Amount (in current US$) in Madagascar?
Provide a succinct answer. 2.86e+09. In the year 1991, what is the difference between the Amount (in current US$) of Cote d'Ivoire and Amount (in current US$) of Guinea?
Give a very brief answer. 3.92e+07. In the year 1991, what is the difference between the Amount (in current US$) in Cote d'Ivoire and Amount (in current US$) in Madagascar?
Your answer should be compact. 2.38e+07. In the year 1991, what is the difference between the Amount (in current US$) of Guinea and Amount (in current US$) of Madagascar?
Make the answer very short. -1.54e+07. In the year 1992, what is the difference between the Amount (in current US$) of Sub-Saharan Africa (developing only) and Amount (in current US$) of Cote d'Ivoire?
Provide a succinct answer. 3.05e+09. In the year 1992, what is the difference between the Amount (in current US$) in Sub-Saharan Africa (developing only) and Amount (in current US$) in Guinea?
Keep it short and to the point. 3.01e+09. In the year 1992, what is the difference between the Amount (in current US$) of Sub-Saharan Africa (developing only) and Amount (in current US$) of Madagascar?
Give a very brief answer. 3.08e+09. In the year 1992, what is the difference between the Amount (in current US$) of Cote d'Ivoire and Amount (in current US$) of Guinea?
Offer a terse response. -3.63e+07. In the year 1992, what is the difference between the Amount (in current US$) in Cote d'Ivoire and Amount (in current US$) in Madagascar?
Your answer should be compact. 3.41e+07. In the year 1992, what is the difference between the Amount (in current US$) in Guinea and Amount (in current US$) in Madagascar?
Your answer should be very brief. 7.04e+07. In the year 1993, what is the difference between the Amount (in current US$) of Sub-Saharan Africa (developing only) and Amount (in current US$) of Guinea?
Give a very brief answer. 2.69e+09. In the year 1993, what is the difference between the Amount (in current US$) of Sub-Saharan Africa (developing only) and Amount (in current US$) of Madagascar?
Give a very brief answer. 2.84e+09. In the year 1993, what is the difference between the Amount (in current US$) in Guinea and Amount (in current US$) in Madagascar?
Your response must be concise. 1.43e+08. In the year 1994, what is the difference between the Amount (in current US$) in Sub-Saharan Africa (developing only) and Amount (in current US$) in Cote d'Ivoire?
Your answer should be compact. 2.71e+09. In the year 1994, what is the difference between the Amount (in current US$) of Sub-Saharan Africa (developing only) and Amount (in current US$) of Guinea?
Offer a terse response. 2.87e+09. In the year 1994, what is the difference between the Amount (in current US$) in Sub-Saharan Africa (developing only) and Amount (in current US$) in Madagascar?
Ensure brevity in your answer.  2.95e+09. In the year 1994, what is the difference between the Amount (in current US$) of Cote d'Ivoire and Amount (in current US$) of Guinea?
Give a very brief answer. 1.60e+08. In the year 1994, what is the difference between the Amount (in current US$) in Cote d'Ivoire and Amount (in current US$) in Madagascar?
Offer a very short reply. 2.38e+08. In the year 1994, what is the difference between the Amount (in current US$) in Guinea and Amount (in current US$) in Madagascar?
Your answer should be very brief. 7.83e+07. What is the ratio of the Amount (in current US$) in Sub-Saharan Africa (developing only) in 1987 to that in 1988?
Provide a succinct answer. 1.14. What is the ratio of the Amount (in current US$) in Cote d'Ivoire in 1987 to that in 1988?
Make the answer very short. 9.14. What is the ratio of the Amount (in current US$) in Guinea in 1987 to that in 1988?
Ensure brevity in your answer.  0.77. What is the ratio of the Amount (in current US$) of Madagascar in 1987 to that in 1988?
Your answer should be very brief. 1.26. What is the ratio of the Amount (in current US$) in Sub-Saharan Africa (developing only) in 1987 to that in 1989?
Provide a succinct answer. 1.1. What is the ratio of the Amount (in current US$) in Cote d'Ivoire in 1987 to that in 1989?
Provide a short and direct response. 20.03. What is the ratio of the Amount (in current US$) of Guinea in 1987 to that in 1989?
Provide a succinct answer. 0.56. What is the ratio of the Amount (in current US$) in Madagascar in 1987 to that in 1989?
Offer a terse response. 1.74. What is the ratio of the Amount (in current US$) in Sub-Saharan Africa (developing only) in 1987 to that in 1990?
Ensure brevity in your answer.  0.96. What is the ratio of the Amount (in current US$) in Cote d'Ivoire in 1987 to that in 1990?
Make the answer very short. 1.25. What is the ratio of the Amount (in current US$) in Guinea in 1987 to that in 1990?
Offer a very short reply. 0.71. What is the ratio of the Amount (in current US$) of Madagascar in 1987 to that in 1990?
Your response must be concise. 1.41. What is the ratio of the Amount (in current US$) in Sub-Saharan Africa (developing only) in 1987 to that in 1991?
Give a very brief answer. 1.03. What is the ratio of the Amount (in current US$) of Cote d'Ivoire in 1987 to that in 1991?
Ensure brevity in your answer.  1.69. What is the ratio of the Amount (in current US$) of Guinea in 1987 to that in 1991?
Make the answer very short. 0.37. What is the ratio of the Amount (in current US$) of Madagascar in 1987 to that in 1991?
Offer a very short reply. 1.12. What is the ratio of the Amount (in current US$) in Sub-Saharan Africa (developing only) in 1987 to that in 1992?
Your answer should be compact. 0.98. What is the ratio of the Amount (in current US$) in Cote d'Ivoire in 1987 to that in 1992?
Your answer should be very brief. 2.96. What is the ratio of the Amount (in current US$) of Guinea in 1987 to that in 1992?
Provide a short and direct response. 0.36. What is the ratio of the Amount (in current US$) in Madagascar in 1987 to that in 1992?
Your response must be concise. 2.61. What is the ratio of the Amount (in current US$) in Sub-Saharan Africa (developing only) in 1987 to that in 1993?
Offer a terse response. 1.06. What is the ratio of the Amount (in current US$) of Guinea in 1987 to that in 1993?
Your answer should be compact. 0.22. What is the ratio of the Amount (in current US$) of Madagascar in 1987 to that in 1993?
Offer a terse response. 2.25. What is the ratio of the Amount (in current US$) of Sub-Saharan Africa (developing only) in 1987 to that in 1994?
Give a very brief answer. 1.03. What is the ratio of the Amount (in current US$) of Cote d'Ivoire in 1987 to that in 1994?
Keep it short and to the point. 0.99. What is the ratio of the Amount (in current US$) in Guinea in 1987 to that in 1994?
Your answer should be very brief. 0.37. What is the ratio of the Amount (in current US$) in Madagascar in 1987 to that in 1994?
Offer a terse response. 3.14. What is the ratio of the Amount (in current US$) of Sub-Saharan Africa (developing only) in 1988 to that in 1989?
Your response must be concise. 0.96. What is the ratio of the Amount (in current US$) of Cote d'Ivoire in 1988 to that in 1989?
Provide a short and direct response. 2.19. What is the ratio of the Amount (in current US$) in Guinea in 1988 to that in 1989?
Your answer should be very brief. 0.72. What is the ratio of the Amount (in current US$) in Madagascar in 1988 to that in 1989?
Your response must be concise. 1.38. What is the ratio of the Amount (in current US$) of Sub-Saharan Africa (developing only) in 1988 to that in 1990?
Your response must be concise. 0.84. What is the ratio of the Amount (in current US$) of Cote d'Ivoire in 1988 to that in 1990?
Ensure brevity in your answer.  0.14. What is the ratio of the Amount (in current US$) in Guinea in 1988 to that in 1990?
Your answer should be very brief. 0.92. What is the ratio of the Amount (in current US$) of Madagascar in 1988 to that in 1990?
Provide a succinct answer. 1.11. What is the ratio of the Amount (in current US$) in Sub-Saharan Africa (developing only) in 1988 to that in 1991?
Give a very brief answer. 0.9. What is the ratio of the Amount (in current US$) in Cote d'Ivoire in 1988 to that in 1991?
Your response must be concise. 0.18. What is the ratio of the Amount (in current US$) in Guinea in 1988 to that in 1991?
Offer a very short reply. 0.48. What is the ratio of the Amount (in current US$) of Madagascar in 1988 to that in 1991?
Your answer should be compact. 0.89. What is the ratio of the Amount (in current US$) in Sub-Saharan Africa (developing only) in 1988 to that in 1992?
Ensure brevity in your answer.  0.86. What is the ratio of the Amount (in current US$) of Cote d'Ivoire in 1988 to that in 1992?
Keep it short and to the point. 0.32. What is the ratio of the Amount (in current US$) of Guinea in 1988 to that in 1992?
Your answer should be compact. 0.47. What is the ratio of the Amount (in current US$) of Madagascar in 1988 to that in 1992?
Your answer should be very brief. 2.07. What is the ratio of the Amount (in current US$) in Sub-Saharan Africa (developing only) in 1988 to that in 1993?
Make the answer very short. 0.93. What is the ratio of the Amount (in current US$) in Guinea in 1988 to that in 1993?
Give a very brief answer. 0.29. What is the ratio of the Amount (in current US$) of Madagascar in 1988 to that in 1993?
Give a very brief answer. 1.78. What is the ratio of the Amount (in current US$) of Sub-Saharan Africa (developing only) in 1988 to that in 1994?
Provide a succinct answer. 0.9. What is the ratio of the Amount (in current US$) of Cote d'Ivoire in 1988 to that in 1994?
Offer a terse response. 0.11. What is the ratio of the Amount (in current US$) of Guinea in 1988 to that in 1994?
Provide a succinct answer. 0.48. What is the ratio of the Amount (in current US$) of Madagascar in 1988 to that in 1994?
Offer a very short reply. 2.48. What is the ratio of the Amount (in current US$) in Sub-Saharan Africa (developing only) in 1989 to that in 1990?
Give a very brief answer. 0.88. What is the ratio of the Amount (in current US$) of Cote d'Ivoire in 1989 to that in 1990?
Your answer should be compact. 0.06. What is the ratio of the Amount (in current US$) of Guinea in 1989 to that in 1990?
Offer a terse response. 1.27. What is the ratio of the Amount (in current US$) of Madagascar in 1989 to that in 1990?
Offer a terse response. 0.81. What is the ratio of the Amount (in current US$) of Sub-Saharan Africa (developing only) in 1989 to that in 1991?
Your answer should be very brief. 0.94. What is the ratio of the Amount (in current US$) in Cote d'Ivoire in 1989 to that in 1991?
Your response must be concise. 0.08. What is the ratio of the Amount (in current US$) in Guinea in 1989 to that in 1991?
Provide a short and direct response. 0.66. What is the ratio of the Amount (in current US$) in Madagascar in 1989 to that in 1991?
Ensure brevity in your answer.  0.65. What is the ratio of the Amount (in current US$) of Sub-Saharan Africa (developing only) in 1989 to that in 1992?
Provide a succinct answer. 0.9. What is the ratio of the Amount (in current US$) of Cote d'Ivoire in 1989 to that in 1992?
Offer a very short reply. 0.15. What is the ratio of the Amount (in current US$) of Guinea in 1989 to that in 1992?
Provide a succinct answer. 0.65. What is the ratio of the Amount (in current US$) of Madagascar in 1989 to that in 1992?
Ensure brevity in your answer.  1.5. What is the ratio of the Amount (in current US$) in Sub-Saharan Africa (developing only) in 1989 to that in 1993?
Your answer should be compact. 0.97. What is the ratio of the Amount (in current US$) in Guinea in 1989 to that in 1993?
Give a very brief answer. 0.4. What is the ratio of the Amount (in current US$) in Madagascar in 1989 to that in 1993?
Offer a terse response. 1.29. What is the ratio of the Amount (in current US$) of Sub-Saharan Africa (developing only) in 1989 to that in 1994?
Provide a succinct answer. 0.94. What is the ratio of the Amount (in current US$) of Cote d'Ivoire in 1989 to that in 1994?
Your response must be concise. 0.05. What is the ratio of the Amount (in current US$) of Guinea in 1989 to that in 1994?
Your response must be concise. 0.66. What is the ratio of the Amount (in current US$) in Madagascar in 1989 to that in 1994?
Keep it short and to the point. 1.8. What is the ratio of the Amount (in current US$) of Sub-Saharan Africa (developing only) in 1990 to that in 1991?
Make the answer very short. 1.07. What is the ratio of the Amount (in current US$) of Cote d'Ivoire in 1990 to that in 1991?
Provide a short and direct response. 1.35. What is the ratio of the Amount (in current US$) of Guinea in 1990 to that in 1991?
Provide a short and direct response. 0.52. What is the ratio of the Amount (in current US$) of Madagascar in 1990 to that in 1991?
Your answer should be compact. 0.8. What is the ratio of the Amount (in current US$) of Sub-Saharan Africa (developing only) in 1990 to that in 1992?
Keep it short and to the point. 1.02. What is the ratio of the Amount (in current US$) of Cote d'Ivoire in 1990 to that in 1992?
Provide a succinct answer. 2.36. What is the ratio of the Amount (in current US$) in Guinea in 1990 to that in 1992?
Give a very brief answer. 0.51. What is the ratio of the Amount (in current US$) of Madagascar in 1990 to that in 1992?
Offer a terse response. 1.86. What is the ratio of the Amount (in current US$) in Sub-Saharan Africa (developing only) in 1990 to that in 1993?
Your response must be concise. 1.1. What is the ratio of the Amount (in current US$) in Guinea in 1990 to that in 1993?
Your response must be concise. 0.32. What is the ratio of the Amount (in current US$) of Madagascar in 1990 to that in 1993?
Provide a succinct answer. 1.6. What is the ratio of the Amount (in current US$) in Sub-Saharan Africa (developing only) in 1990 to that in 1994?
Your answer should be very brief. 1.07. What is the ratio of the Amount (in current US$) in Cote d'Ivoire in 1990 to that in 1994?
Your answer should be very brief. 0.79. What is the ratio of the Amount (in current US$) of Guinea in 1990 to that in 1994?
Ensure brevity in your answer.  0.52. What is the ratio of the Amount (in current US$) in Madagascar in 1990 to that in 1994?
Keep it short and to the point. 2.23. What is the ratio of the Amount (in current US$) in Sub-Saharan Africa (developing only) in 1991 to that in 1992?
Provide a succinct answer. 0.96. What is the ratio of the Amount (in current US$) in Cote d'Ivoire in 1991 to that in 1992?
Provide a short and direct response. 1.75. What is the ratio of the Amount (in current US$) of Guinea in 1991 to that in 1992?
Make the answer very short. 0.98. What is the ratio of the Amount (in current US$) of Madagascar in 1991 to that in 1992?
Your response must be concise. 2.32. What is the ratio of the Amount (in current US$) in Sub-Saharan Africa (developing only) in 1991 to that in 1993?
Offer a very short reply. 1.03. What is the ratio of the Amount (in current US$) of Guinea in 1991 to that in 1993?
Make the answer very short. 0.6. What is the ratio of the Amount (in current US$) in Madagascar in 1991 to that in 1993?
Offer a terse response. 2. What is the ratio of the Amount (in current US$) in Cote d'Ivoire in 1991 to that in 1994?
Give a very brief answer. 0.58. What is the ratio of the Amount (in current US$) in Guinea in 1991 to that in 1994?
Provide a short and direct response. 1. What is the ratio of the Amount (in current US$) in Madagascar in 1991 to that in 1994?
Your response must be concise. 2.79. What is the ratio of the Amount (in current US$) in Sub-Saharan Africa (developing only) in 1992 to that in 1993?
Offer a terse response. 1.08. What is the ratio of the Amount (in current US$) in Guinea in 1992 to that in 1993?
Make the answer very short. 0.62. What is the ratio of the Amount (in current US$) in Madagascar in 1992 to that in 1993?
Your answer should be very brief. 0.86. What is the ratio of the Amount (in current US$) of Sub-Saharan Africa (developing only) in 1992 to that in 1994?
Your answer should be compact. 1.05. What is the ratio of the Amount (in current US$) in Cote d'Ivoire in 1992 to that in 1994?
Offer a very short reply. 0.33. What is the ratio of the Amount (in current US$) of Guinea in 1992 to that in 1994?
Make the answer very short. 1.02. What is the ratio of the Amount (in current US$) in Madagascar in 1992 to that in 1994?
Your answer should be compact. 1.2. What is the ratio of the Amount (in current US$) of Sub-Saharan Africa (developing only) in 1993 to that in 1994?
Your response must be concise. 0.97. What is the ratio of the Amount (in current US$) in Guinea in 1993 to that in 1994?
Your response must be concise. 1.66. What is the ratio of the Amount (in current US$) of Madagascar in 1993 to that in 1994?
Offer a terse response. 1.4. What is the difference between the highest and the second highest Amount (in current US$) of Sub-Saharan Africa (developing only)?
Offer a terse response. 6.18e+07. What is the difference between the highest and the second highest Amount (in current US$) of Cote d'Ivoire?
Make the answer very short. 3.87e+06. What is the difference between the highest and the second highest Amount (in current US$) in Guinea?
Make the answer very short. 8.31e+07. What is the difference between the highest and the second highest Amount (in current US$) of Madagascar?
Provide a short and direct response. 1.81e+07. What is the difference between the highest and the lowest Amount (in current US$) of Sub-Saharan Africa (developing only)?
Your response must be concise. 5.05e+08. What is the difference between the highest and the lowest Amount (in current US$) in Cote d'Ivoire?
Offer a terse response. 2.91e+08. What is the difference between the highest and the lowest Amount (in current US$) of Guinea?
Provide a succinct answer. 1.68e+08. What is the difference between the highest and the lowest Amount (in current US$) of Madagascar?
Give a very brief answer. 1.12e+08. 